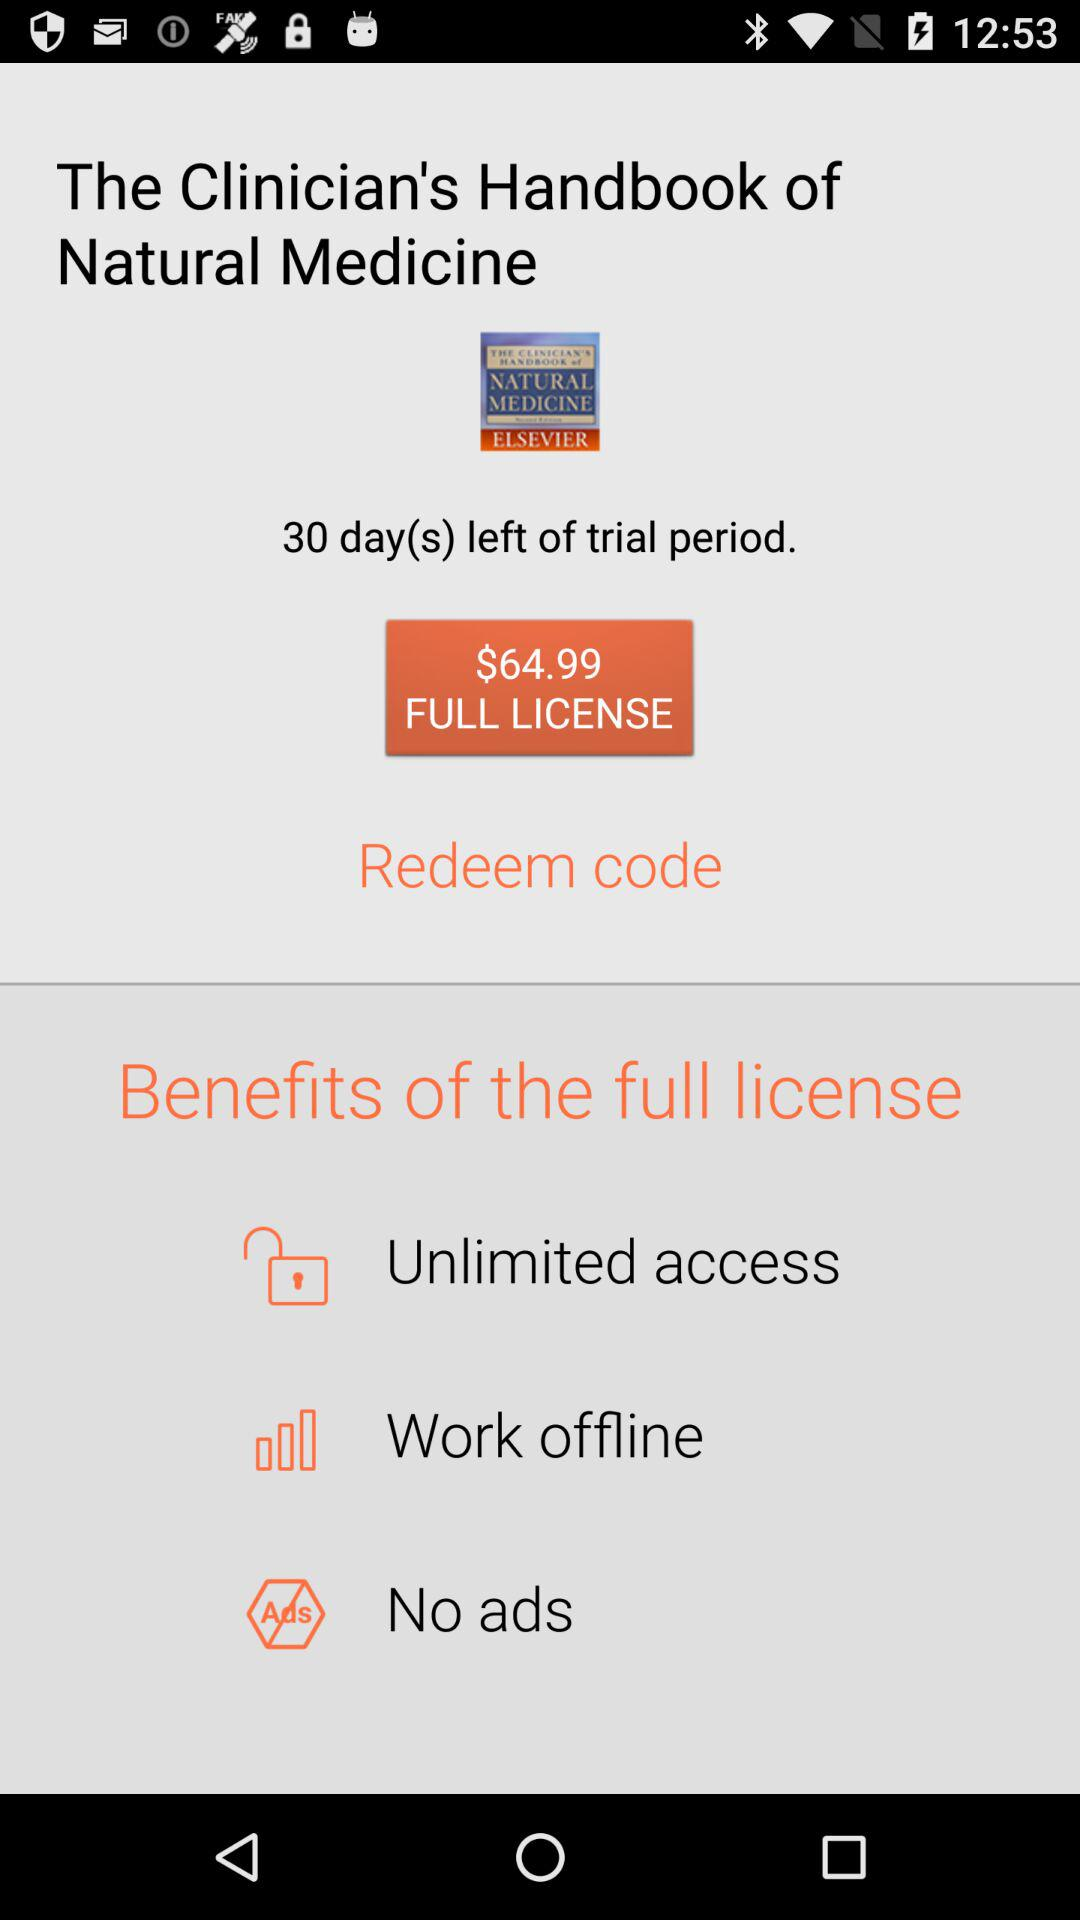How much is the full license?
Answer the question using a single word or phrase. $64.99 